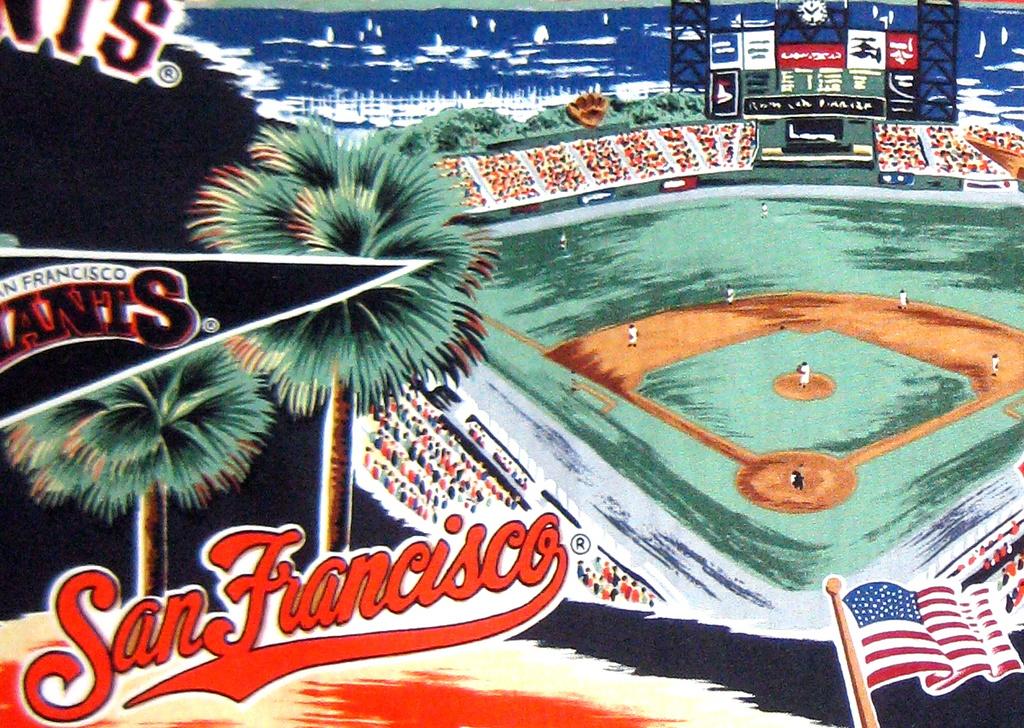What flag is this from?
Provide a short and direct response. San francisco. 